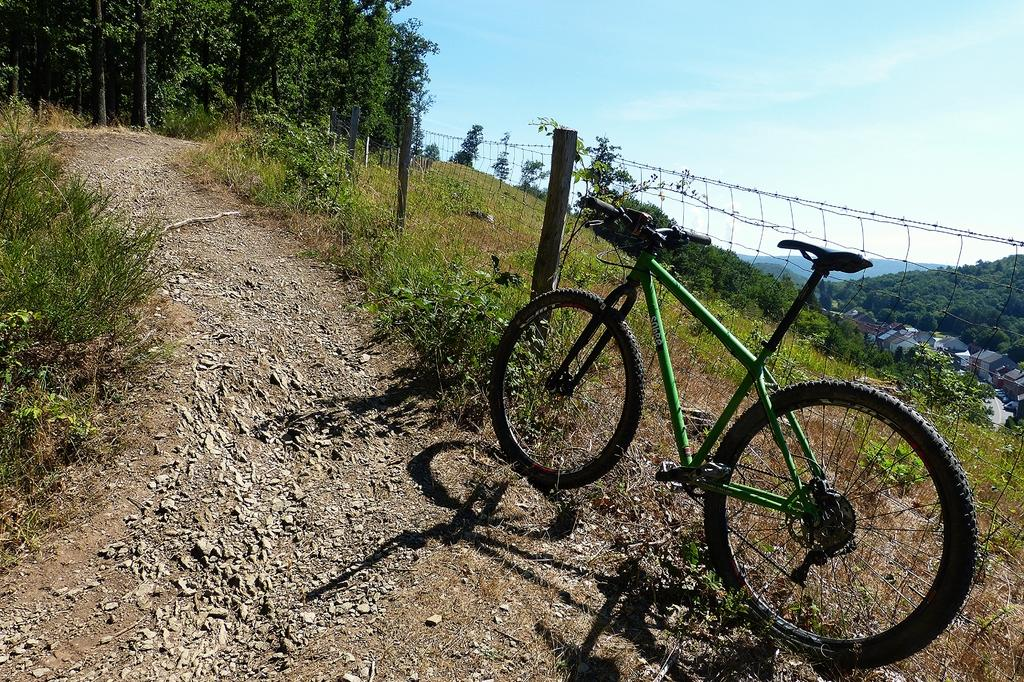What is the main object in the image? There is a bicycle in the image. What type of terrain is visible in the image? There is grass, trees, and hills in the image. What can be seen in the sky in the image? The sky is visible in the image. Can you tell me where the locket is hidden in the image? There is no locket present in the image. How does the guide help the person in the image? There is no guide or person present in the image. 